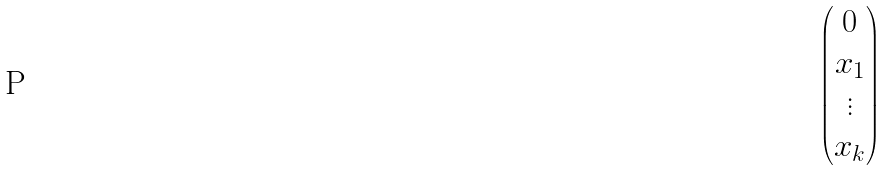Convert formula to latex. <formula><loc_0><loc_0><loc_500><loc_500>\begin{pmatrix} 0 \\ x _ { 1 } \\ \vdots \\ x _ { k } \end{pmatrix}</formula> 